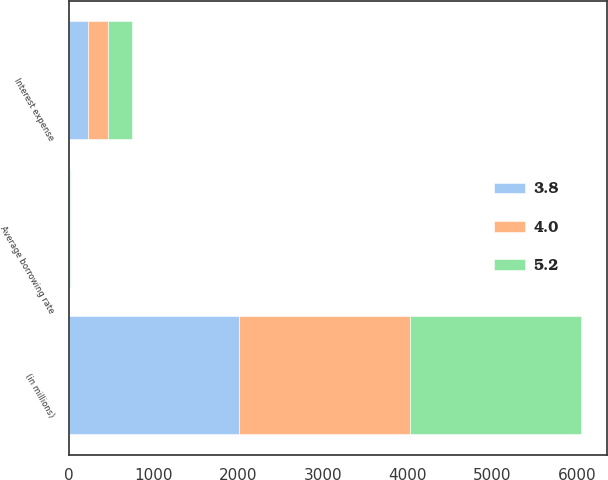Convert chart to OTSL. <chart><loc_0><loc_0><loc_500><loc_500><stacked_bar_chart><ecel><fcel>(in millions)<fcel>Interest expense<fcel>Average borrowing rate<nl><fcel>3.8<fcel>2017<fcel>229<fcel>3.8<nl><fcel>4<fcel>2016<fcel>233<fcel>4<nl><fcel>5.2<fcel>2015<fcel>284<fcel>5.2<nl></chart> 